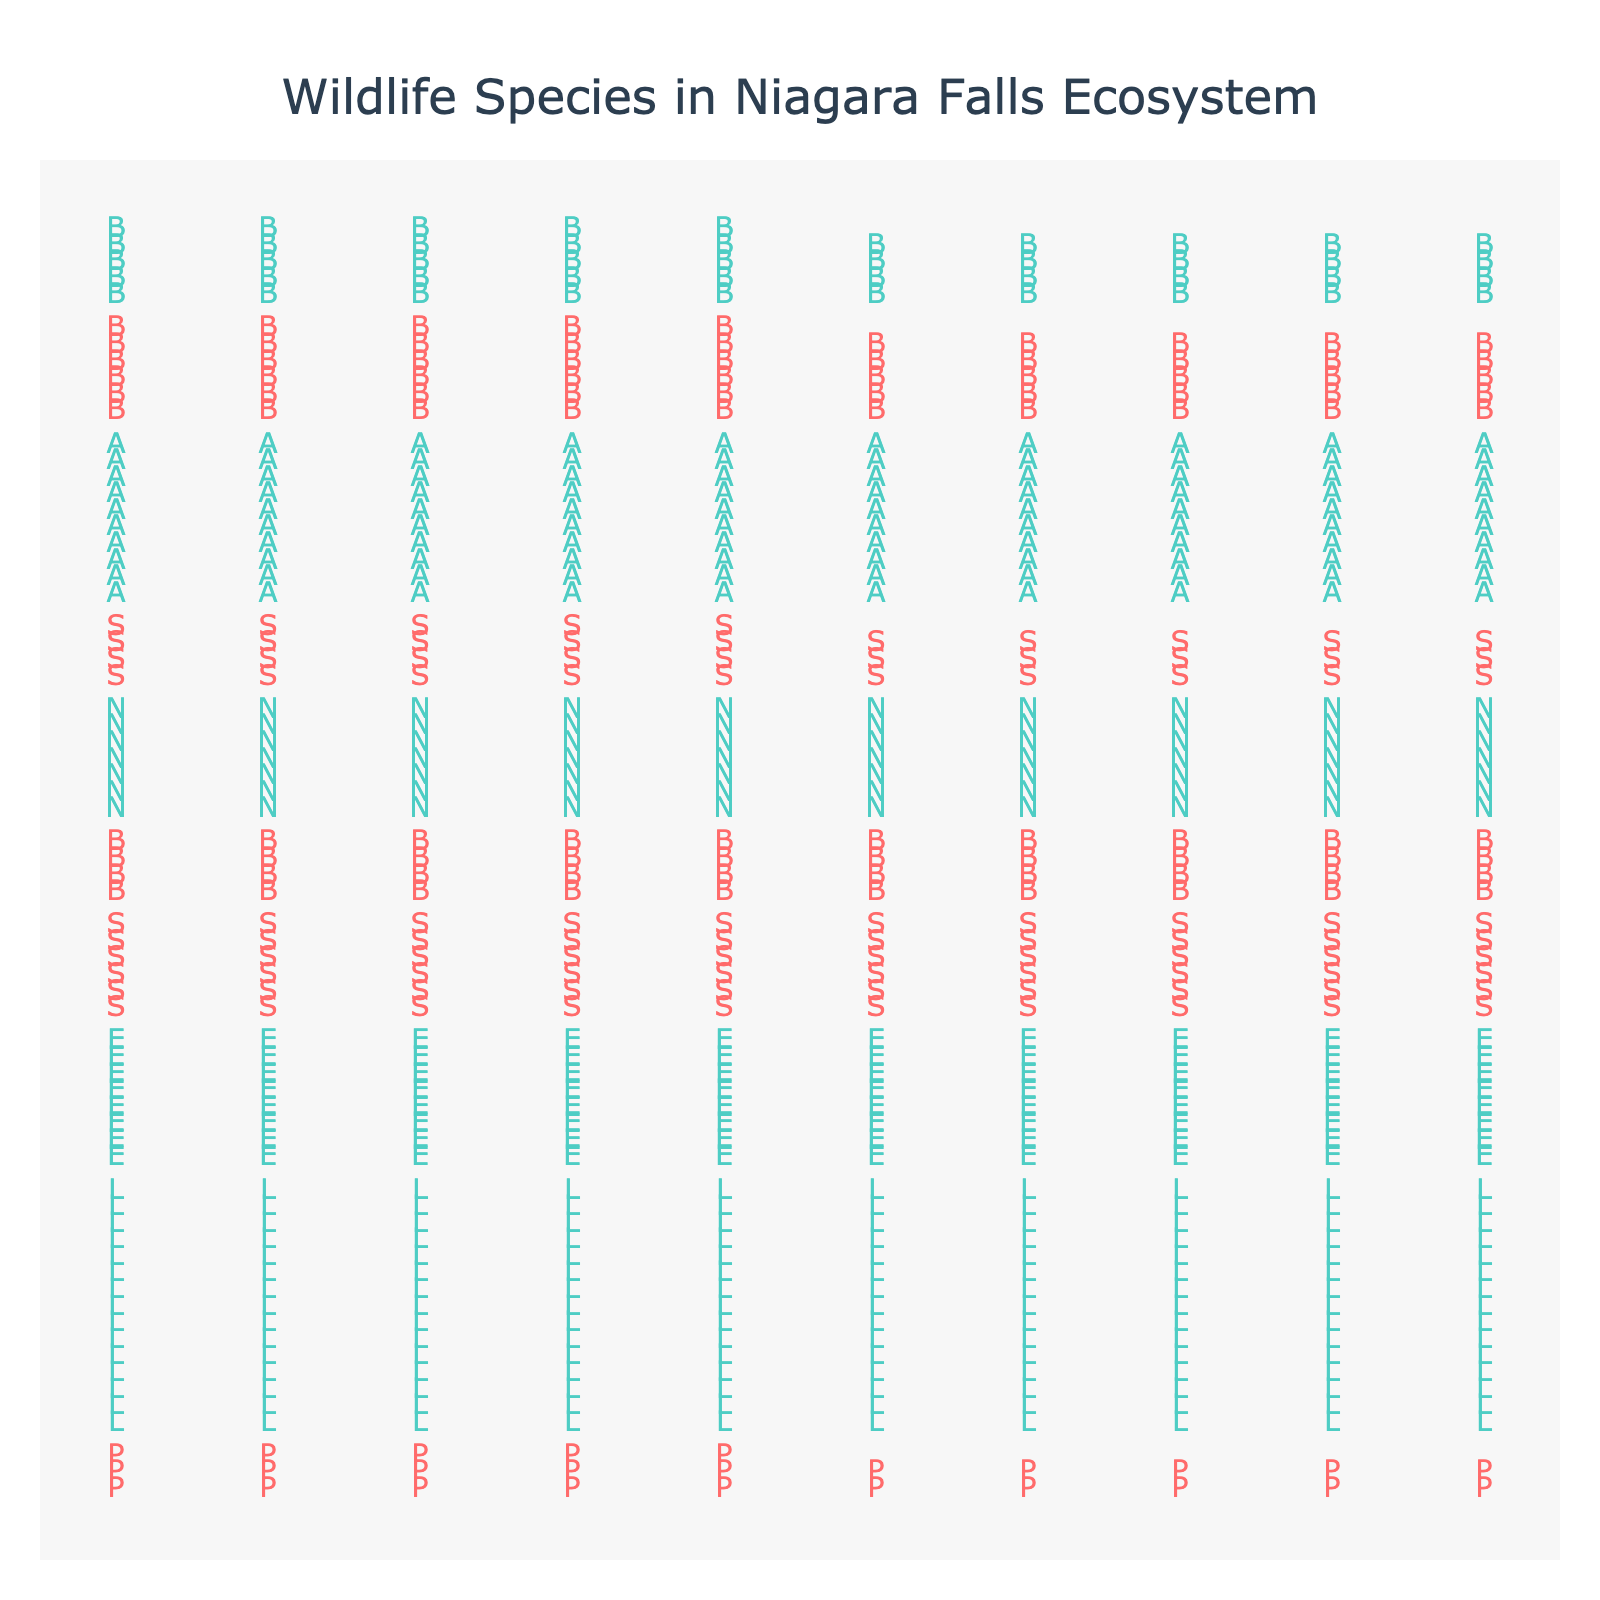What is the total population of all endangered species shown in the plot? Sum the populations of all species categorized as endangered: Peregrine Falcon (25), Shumard Oak (60), Butternut Tree (40), Spotted Turtle (35), Blanchard's Cricket Frog (55). Total = 25 + 60 + 40 + 35 + 55 = 215
Answer: 215 What colors are used to represent endangered and threatened species? Endangered species are represented by a red color, while threatened species are shown in green.
Answer: Red and green Which species has the highest population, and what is its conservation status? By looking at the figure, Lake Sturgeon has the highest population of 150, and its status is threatened.
Answer: Lake Sturgeon, threatened How many species in total are represented in the plot? Count each unique species listed in the figure's legend or individually marked, there are 10 species in total.
Answer: 10 What is the average population of threatened species? Calculate the populations of the threatened species: Lake Sturgeon (150), Eastern Massasauga Rattlesnake (80), Northern Long-eared Bat (70), American Ginseng (100), Blanding's Turtle (45). Total population = 150 + 80 + 70 + 100 + 45 = 445. Number of threatened species = 5. Average = 445/5 = 89
Answer: 89 Which endangered species has the lowest population? By looking at the species categorized as endangered and their populations, the Peregrine Falcon has the lowest with a population of 25.
Answer: Peregrine Falcon Are there more endangered or threatened species? Count the number of endangered species (5) and compare it to the number of threatened species (5). Both categories have the same number of species.
Answer: Equal (5 each) What is the difference in population between the species with the highest population and the species with the lowest population? The species with the highest population is the Lake Sturgeon (150) and the species with the lowest population is the Peregrine Falcon (25). Difference = 150 - 25 = 125
Answer: 125 What is the total population of all species combined? Sum the populations of all species displayed: 25 + 150 + 80 + 60 + 40 + 70 + 35 + 100 + 55 + 45. Total = 660
Answer: 660 